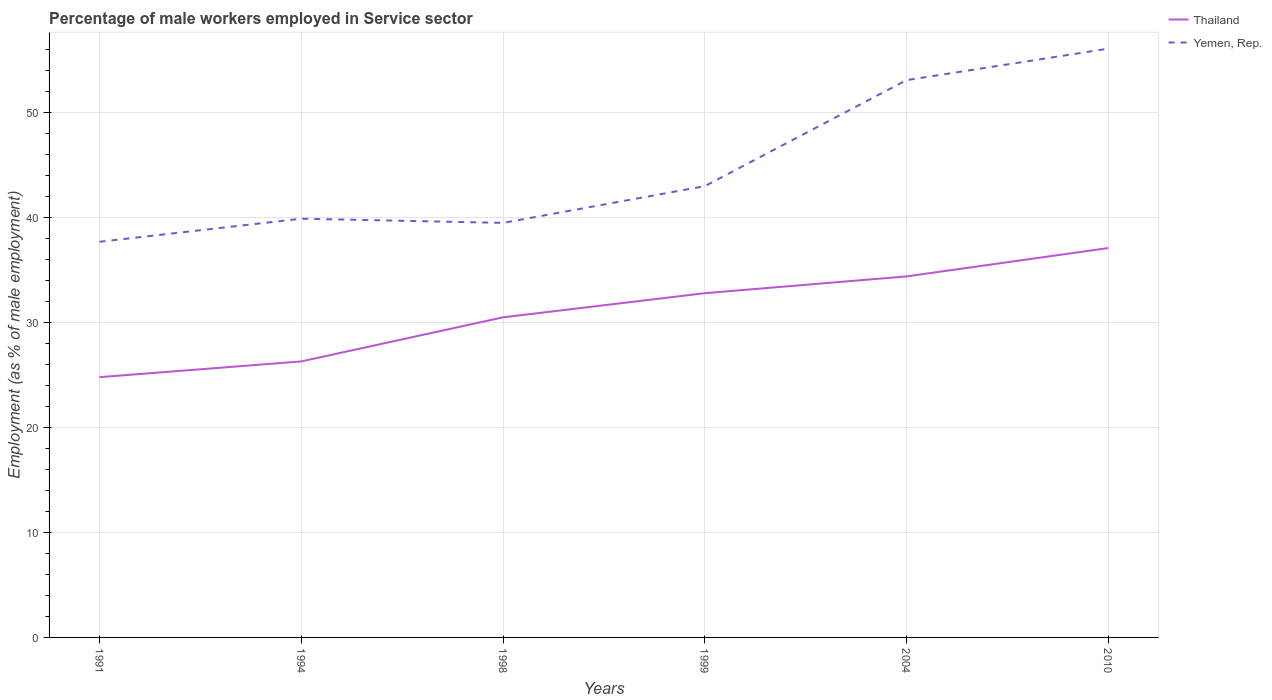Across all years, what is the maximum percentage of male workers employed in Service sector in Thailand?
Keep it short and to the point. 24.8. In which year was the percentage of male workers employed in Service sector in Yemen, Rep. maximum?
Give a very brief answer. 1991. What is the total percentage of male workers employed in Service sector in Yemen, Rep. in the graph?
Ensure brevity in your answer.  -18.4. What is the difference between the highest and the second highest percentage of male workers employed in Service sector in Yemen, Rep.?
Your answer should be very brief. 18.4. Is the percentage of male workers employed in Service sector in Thailand strictly greater than the percentage of male workers employed in Service sector in Yemen, Rep. over the years?
Ensure brevity in your answer.  Yes. How many lines are there?
Your answer should be compact. 2. Are the values on the major ticks of Y-axis written in scientific E-notation?
Your response must be concise. No. Does the graph contain any zero values?
Offer a terse response. No. Does the graph contain grids?
Provide a succinct answer. Yes. How many legend labels are there?
Offer a very short reply. 2. What is the title of the graph?
Offer a terse response. Percentage of male workers employed in Service sector. What is the label or title of the Y-axis?
Your answer should be compact. Employment (as % of male employment). What is the Employment (as % of male employment) in Thailand in 1991?
Keep it short and to the point. 24.8. What is the Employment (as % of male employment) in Yemen, Rep. in 1991?
Offer a terse response. 37.7. What is the Employment (as % of male employment) of Thailand in 1994?
Offer a very short reply. 26.3. What is the Employment (as % of male employment) of Yemen, Rep. in 1994?
Make the answer very short. 39.9. What is the Employment (as % of male employment) in Thailand in 1998?
Your response must be concise. 30.5. What is the Employment (as % of male employment) of Yemen, Rep. in 1998?
Your answer should be very brief. 39.5. What is the Employment (as % of male employment) in Thailand in 1999?
Provide a succinct answer. 32.8. What is the Employment (as % of male employment) of Thailand in 2004?
Offer a terse response. 34.4. What is the Employment (as % of male employment) of Yemen, Rep. in 2004?
Make the answer very short. 53.1. What is the Employment (as % of male employment) in Thailand in 2010?
Your answer should be compact. 37.1. What is the Employment (as % of male employment) in Yemen, Rep. in 2010?
Your response must be concise. 56.1. Across all years, what is the maximum Employment (as % of male employment) of Thailand?
Ensure brevity in your answer.  37.1. Across all years, what is the maximum Employment (as % of male employment) of Yemen, Rep.?
Make the answer very short. 56.1. Across all years, what is the minimum Employment (as % of male employment) in Thailand?
Offer a terse response. 24.8. Across all years, what is the minimum Employment (as % of male employment) in Yemen, Rep.?
Your answer should be very brief. 37.7. What is the total Employment (as % of male employment) of Thailand in the graph?
Offer a very short reply. 185.9. What is the total Employment (as % of male employment) in Yemen, Rep. in the graph?
Your answer should be compact. 269.3. What is the difference between the Employment (as % of male employment) of Yemen, Rep. in 1991 and that in 1998?
Offer a terse response. -1.8. What is the difference between the Employment (as % of male employment) in Thailand in 1991 and that in 1999?
Provide a short and direct response. -8. What is the difference between the Employment (as % of male employment) in Thailand in 1991 and that in 2004?
Provide a short and direct response. -9.6. What is the difference between the Employment (as % of male employment) in Yemen, Rep. in 1991 and that in 2004?
Keep it short and to the point. -15.4. What is the difference between the Employment (as % of male employment) of Yemen, Rep. in 1991 and that in 2010?
Offer a very short reply. -18.4. What is the difference between the Employment (as % of male employment) of Thailand in 1994 and that in 1998?
Provide a short and direct response. -4.2. What is the difference between the Employment (as % of male employment) in Yemen, Rep. in 1994 and that in 2004?
Provide a short and direct response. -13.2. What is the difference between the Employment (as % of male employment) of Thailand in 1994 and that in 2010?
Your answer should be very brief. -10.8. What is the difference between the Employment (as % of male employment) in Yemen, Rep. in 1994 and that in 2010?
Your answer should be very brief. -16.2. What is the difference between the Employment (as % of male employment) in Yemen, Rep. in 1998 and that in 1999?
Ensure brevity in your answer.  -3.5. What is the difference between the Employment (as % of male employment) in Thailand in 1998 and that in 2004?
Your response must be concise. -3.9. What is the difference between the Employment (as % of male employment) of Thailand in 1998 and that in 2010?
Make the answer very short. -6.6. What is the difference between the Employment (as % of male employment) of Yemen, Rep. in 1998 and that in 2010?
Offer a very short reply. -16.6. What is the difference between the Employment (as % of male employment) in Thailand in 1999 and that in 2004?
Make the answer very short. -1.6. What is the difference between the Employment (as % of male employment) in Yemen, Rep. in 1999 and that in 2004?
Keep it short and to the point. -10.1. What is the difference between the Employment (as % of male employment) of Thailand in 1999 and that in 2010?
Your answer should be very brief. -4.3. What is the difference between the Employment (as % of male employment) of Yemen, Rep. in 1999 and that in 2010?
Make the answer very short. -13.1. What is the difference between the Employment (as % of male employment) of Thailand in 2004 and that in 2010?
Offer a terse response. -2.7. What is the difference between the Employment (as % of male employment) of Yemen, Rep. in 2004 and that in 2010?
Your answer should be very brief. -3. What is the difference between the Employment (as % of male employment) in Thailand in 1991 and the Employment (as % of male employment) in Yemen, Rep. in 1994?
Offer a very short reply. -15.1. What is the difference between the Employment (as % of male employment) in Thailand in 1991 and the Employment (as % of male employment) in Yemen, Rep. in 1998?
Ensure brevity in your answer.  -14.7. What is the difference between the Employment (as % of male employment) in Thailand in 1991 and the Employment (as % of male employment) in Yemen, Rep. in 1999?
Your answer should be very brief. -18.2. What is the difference between the Employment (as % of male employment) of Thailand in 1991 and the Employment (as % of male employment) of Yemen, Rep. in 2004?
Your response must be concise. -28.3. What is the difference between the Employment (as % of male employment) in Thailand in 1991 and the Employment (as % of male employment) in Yemen, Rep. in 2010?
Provide a succinct answer. -31.3. What is the difference between the Employment (as % of male employment) in Thailand in 1994 and the Employment (as % of male employment) in Yemen, Rep. in 1999?
Make the answer very short. -16.7. What is the difference between the Employment (as % of male employment) in Thailand in 1994 and the Employment (as % of male employment) in Yemen, Rep. in 2004?
Provide a short and direct response. -26.8. What is the difference between the Employment (as % of male employment) in Thailand in 1994 and the Employment (as % of male employment) in Yemen, Rep. in 2010?
Offer a terse response. -29.8. What is the difference between the Employment (as % of male employment) in Thailand in 1998 and the Employment (as % of male employment) in Yemen, Rep. in 2004?
Give a very brief answer. -22.6. What is the difference between the Employment (as % of male employment) of Thailand in 1998 and the Employment (as % of male employment) of Yemen, Rep. in 2010?
Offer a very short reply. -25.6. What is the difference between the Employment (as % of male employment) of Thailand in 1999 and the Employment (as % of male employment) of Yemen, Rep. in 2004?
Offer a very short reply. -20.3. What is the difference between the Employment (as % of male employment) of Thailand in 1999 and the Employment (as % of male employment) of Yemen, Rep. in 2010?
Offer a terse response. -23.3. What is the difference between the Employment (as % of male employment) of Thailand in 2004 and the Employment (as % of male employment) of Yemen, Rep. in 2010?
Make the answer very short. -21.7. What is the average Employment (as % of male employment) in Thailand per year?
Give a very brief answer. 30.98. What is the average Employment (as % of male employment) in Yemen, Rep. per year?
Your answer should be compact. 44.88. In the year 1998, what is the difference between the Employment (as % of male employment) of Thailand and Employment (as % of male employment) of Yemen, Rep.?
Your answer should be compact. -9. In the year 1999, what is the difference between the Employment (as % of male employment) in Thailand and Employment (as % of male employment) in Yemen, Rep.?
Provide a short and direct response. -10.2. In the year 2004, what is the difference between the Employment (as % of male employment) of Thailand and Employment (as % of male employment) of Yemen, Rep.?
Provide a succinct answer. -18.7. What is the ratio of the Employment (as % of male employment) in Thailand in 1991 to that in 1994?
Make the answer very short. 0.94. What is the ratio of the Employment (as % of male employment) in Yemen, Rep. in 1991 to that in 1994?
Offer a terse response. 0.94. What is the ratio of the Employment (as % of male employment) in Thailand in 1991 to that in 1998?
Make the answer very short. 0.81. What is the ratio of the Employment (as % of male employment) in Yemen, Rep. in 1991 to that in 1998?
Keep it short and to the point. 0.95. What is the ratio of the Employment (as % of male employment) in Thailand in 1991 to that in 1999?
Offer a terse response. 0.76. What is the ratio of the Employment (as % of male employment) in Yemen, Rep. in 1991 to that in 1999?
Give a very brief answer. 0.88. What is the ratio of the Employment (as % of male employment) of Thailand in 1991 to that in 2004?
Make the answer very short. 0.72. What is the ratio of the Employment (as % of male employment) of Yemen, Rep. in 1991 to that in 2004?
Make the answer very short. 0.71. What is the ratio of the Employment (as % of male employment) in Thailand in 1991 to that in 2010?
Give a very brief answer. 0.67. What is the ratio of the Employment (as % of male employment) in Yemen, Rep. in 1991 to that in 2010?
Provide a succinct answer. 0.67. What is the ratio of the Employment (as % of male employment) in Thailand in 1994 to that in 1998?
Offer a terse response. 0.86. What is the ratio of the Employment (as % of male employment) of Yemen, Rep. in 1994 to that in 1998?
Give a very brief answer. 1.01. What is the ratio of the Employment (as % of male employment) of Thailand in 1994 to that in 1999?
Offer a very short reply. 0.8. What is the ratio of the Employment (as % of male employment) of Yemen, Rep. in 1994 to that in 1999?
Give a very brief answer. 0.93. What is the ratio of the Employment (as % of male employment) of Thailand in 1994 to that in 2004?
Provide a succinct answer. 0.76. What is the ratio of the Employment (as % of male employment) in Yemen, Rep. in 1994 to that in 2004?
Provide a short and direct response. 0.75. What is the ratio of the Employment (as % of male employment) in Thailand in 1994 to that in 2010?
Provide a short and direct response. 0.71. What is the ratio of the Employment (as % of male employment) in Yemen, Rep. in 1994 to that in 2010?
Offer a very short reply. 0.71. What is the ratio of the Employment (as % of male employment) in Thailand in 1998 to that in 1999?
Offer a very short reply. 0.93. What is the ratio of the Employment (as % of male employment) of Yemen, Rep. in 1998 to that in 1999?
Offer a very short reply. 0.92. What is the ratio of the Employment (as % of male employment) in Thailand in 1998 to that in 2004?
Make the answer very short. 0.89. What is the ratio of the Employment (as % of male employment) in Yemen, Rep. in 1998 to that in 2004?
Make the answer very short. 0.74. What is the ratio of the Employment (as % of male employment) of Thailand in 1998 to that in 2010?
Your answer should be compact. 0.82. What is the ratio of the Employment (as % of male employment) in Yemen, Rep. in 1998 to that in 2010?
Offer a terse response. 0.7. What is the ratio of the Employment (as % of male employment) in Thailand in 1999 to that in 2004?
Give a very brief answer. 0.95. What is the ratio of the Employment (as % of male employment) in Yemen, Rep. in 1999 to that in 2004?
Offer a terse response. 0.81. What is the ratio of the Employment (as % of male employment) in Thailand in 1999 to that in 2010?
Make the answer very short. 0.88. What is the ratio of the Employment (as % of male employment) of Yemen, Rep. in 1999 to that in 2010?
Offer a very short reply. 0.77. What is the ratio of the Employment (as % of male employment) in Thailand in 2004 to that in 2010?
Provide a short and direct response. 0.93. What is the ratio of the Employment (as % of male employment) of Yemen, Rep. in 2004 to that in 2010?
Ensure brevity in your answer.  0.95. What is the difference between the highest and the second highest Employment (as % of male employment) in Yemen, Rep.?
Your answer should be very brief. 3. 